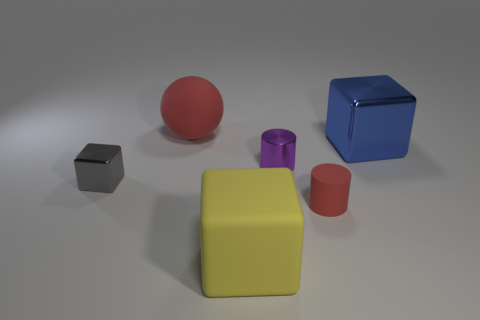Subtract all large yellow rubber cubes. How many cubes are left? 2 Add 3 blue blocks. How many objects exist? 9 Subtract all cylinders. How many objects are left? 4 Subtract all purple blocks. Subtract all green spheres. How many blocks are left? 3 Add 5 large blue cubes. How many large blue cubes are left? 6 Add 4 matte cylinders. How many matte cylinders exist? 5 Subtract 0 cyan cylinders. How many objects are left? 6 Subtract all yellow balls. Subtract all big yellow rubber cubes. How many objects are left? 5 